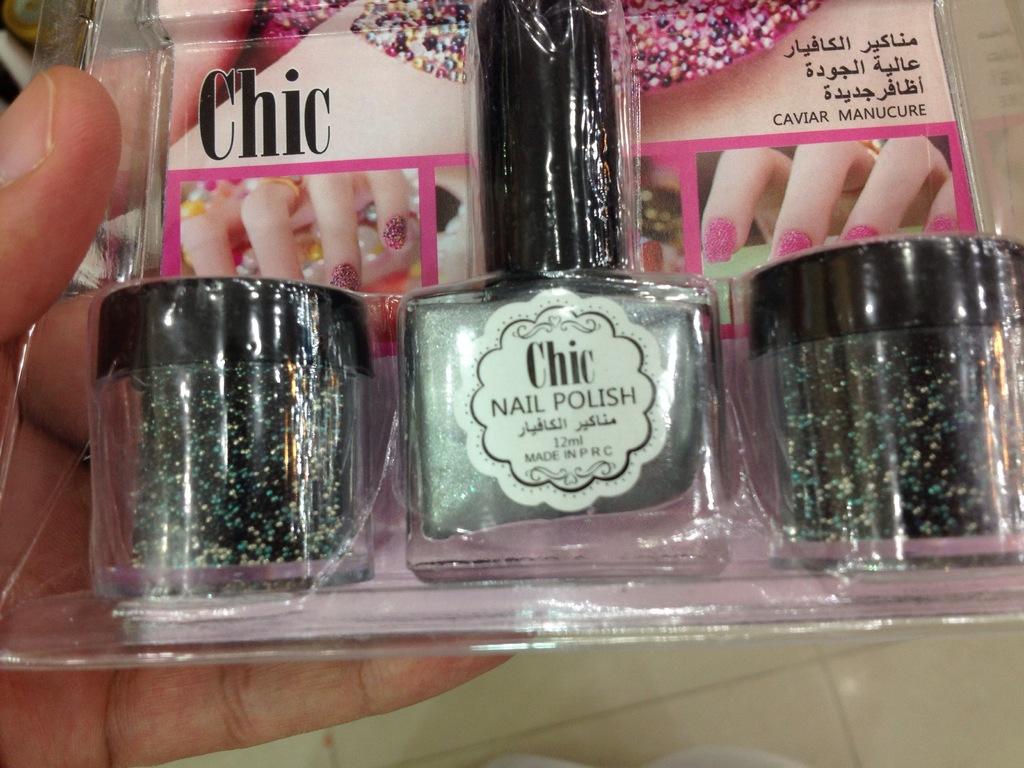What brand nail polish is displayed in the picture?
Your answer should be very brief. Chic. 